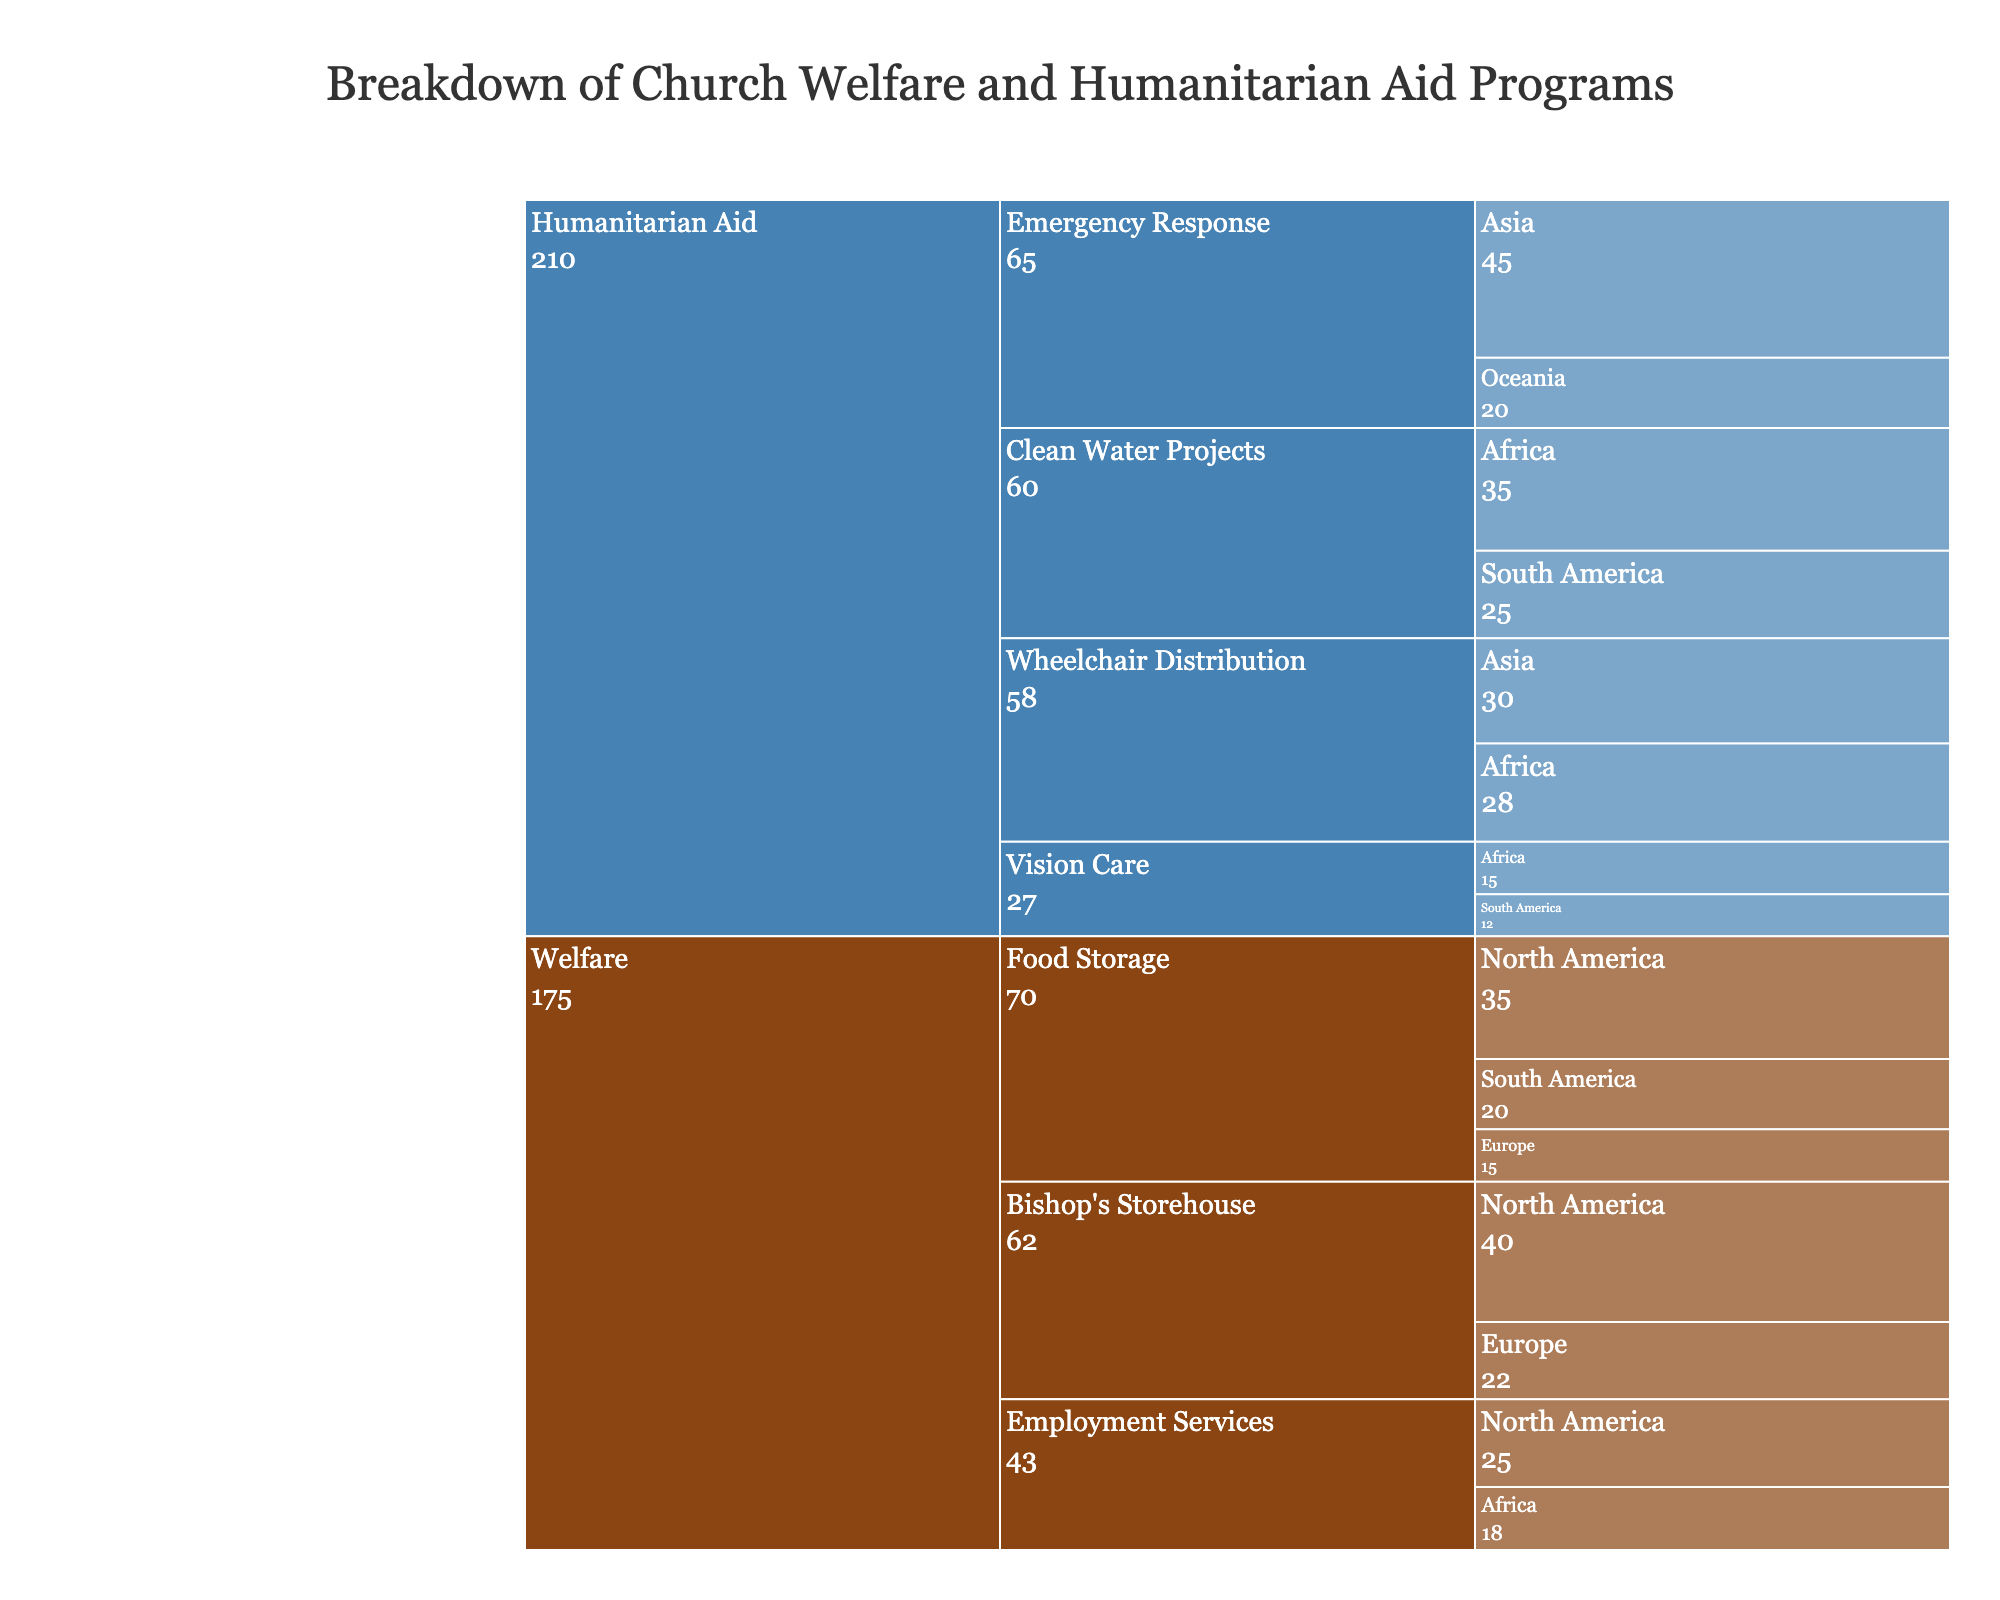what is the total value of Welfare programs in North America? To find the total value of Welfare programs in North America, sum the values of respective welfare types: 35 (Food Storage) + 25 (Employment Services) + 40 (Bishop's Storehouse) = 100
Answer: 100 Which region received the most Wheelchair Distribution under Humanitarian Aid? Look for the highest value under the Wheelchair Distribution category. Asia has 30, while Africa has 28. Asia is the largest
Answer: Asia What is the difference in total value between Humanitarian Aid and Welfare programs? Sum the values of both categories: Welfare = 35+20+15+25+18+40+22 = 175; Humanitarian Aid = 30+28+35+25+45+20+15+12 = 210. The difference is 210 - 175 = 35
Answer: 35 Which type of Humanitarian Aid is provided in the most regions? Count different regions within each Humanitarian Aid type. Wheelchair Distribution has 2 regions (Asia, Africa), Clean Water Projects has 2 regions (Africa, South America), Emergency Response has 2 regions (Asia, Oceania), Vision Care has 2 regions (Africa, South America). They all have the same number of regions
Answer: All types have the same number of regions What is the combined value of Emergency Response and Clean Water Projects in Asia and Africa? Sum the values of Emergency Response in Asia (45) and Clean Water Projects in Africa (35): 45 + 35 = 80
Answer: 80 Which region receives the least value in Welfare programs? Compare the total welfare values by region: North America (35+25+40 = 100), South America (20), Europe (15+22 = 37), Africa (18). South America has the least value
Answer: South America What's the average value per type under Welfare programs? Firstly, count the types of Welfare programs (3: Food Storage, Employment Services, Bishop's Storehouse). Then, sum the values: 35+20+15+25+18+40+22 = 175. Finally, calculate the average: 175 / 3 ≈ 58.33
Answer: 58.33 Which category has the highest total value, and what is it? Sum the total values of each category: Welfare = 35+20+15+25+18+40+22 = 175, Humanitarian Aid = 30+28+35+25+45+20+15+12 = 210. Humanitarian Aid has the highest value with 210
Answer: Humanitarian Aid, 210 